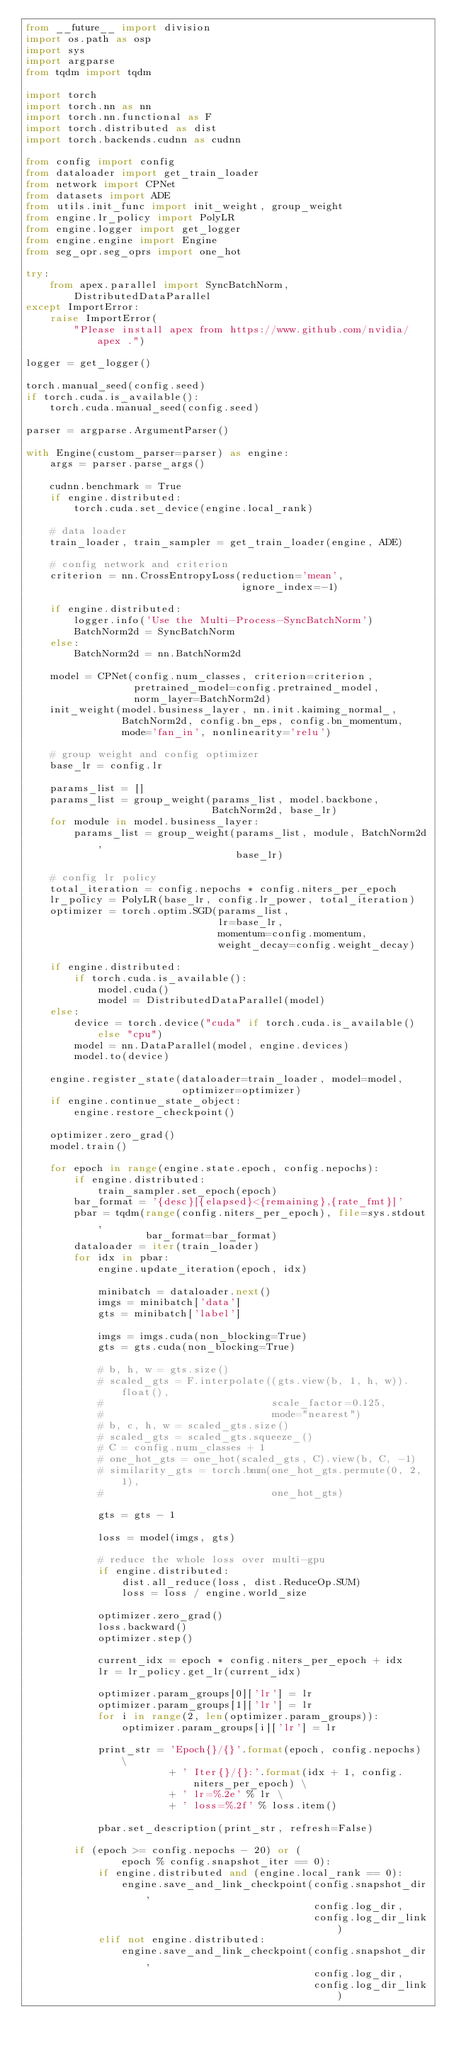<code> <loc_0><loc_0><loc_500><loc_500><_Python_>from __future__ import division
import os.path as osp
import sys
import argparse
from tqdm import tqdm

import torch
import torch.nn as nn
import torch.nn.functional as F
import torch.distributed as dist
import torch.backends.cudnn as cudnn

from config import config
from dataloader import get_train_loader
from network import CPNet
from datasets import ADE
from utils.init_func import init_weight, group_weight
from engine.lr_policy import PolyLR
from engine.logger import get_logger
from engine.engine import Engine
from seg_opr.seg_oprs import one_hot

try:
    from apex.parallel import SyncBatchNorm, DistributedDataParallel
except ImportError:
    raise ImportError(
        "Please install apex from https://www.github.com/nvidia/apex .")

logger = get_logger()

torch.manual_seed(config.seed)
if torch.cuda.is_available():
    torch.cuda.manual_seed(config.seed)

parser = argparse.ArgumentParser()

with Engine(custom_parser=parser) as engine:
    args = parser.parse_args()

    cudnn.benchmark = True
    if engine.distributed:
        torch.cuda.set_device(engine.local_rank)

    # data loader
    train_loader, train_sampler = get_train_loader(engine, ADE)

    # config network and criterion
    criterion = nn.CrossEntropyLoss(reduction='mean',
                                    ignore_index=-1)

    if engine.distributed:
        logger.info('Use the Multi-Process-SyncBatchNorm')
        BatchNorm2d = SyncBatchNorm
    else:
        BatchNorm2d = nn.BatchNorm2d

    model = CPNet(config.num_classes, criterion=criterion,
                  pretrained_model=config.pretrained_model,
                  norm_layer=BatchNorm2d)
    init_weight(model.business_layer, nn.init.kaiming_normal_,
                BatchNorm2d, config.bn_eps, config.bn_momentum,
                mode='fan_in', nonlinearity='relu')

    # group weight and config optimizer
    base_lr = config.lr

    params_list = []
    params_list = group_weight(params_list, model.backbone,
                               BatchNorm2d, base_lr)
    for module in model.business_layer:
        params_list = group_weight(params_list, module, BatchNorm2d,
                                   base_lr)

    # config lr policy
    total_iteration = config.nepochs * config.niters_per_epoch
    lr_policy = PolyLR(base_lr, config.lr_power, total_iteration)
    optimizer = torch.optim.SGD(params_list,
                                lr=base_lr,
                                momentum=config.momentum,
                                weight_decay=config.weight_decay)

    if engine.distributed:
        if torch.cuda.is_available():
            model.cuda()
            model = DistributedDataParallel(model)
    else:
        device = torch.device("cuda" if torch.cuda.is_available() else "cpu")
        model = nn.DataParallel(model, engine.devices)
        model.to(device)

    engine.register_state(dataloader=train_loader, model=model,
                          optimizer=optimizer)
    if engine.continue_state_object:
        engine.restore_checkpoint()

    optimizer.zero_grad()
    model.train()

    for epoch in range(engine.state.epoch, config.nepochs):
        if engine.distributed:
            train_sampler.set_epoch(epoch)
        bar_format = '{desc}[{elapsed}<{remaining},{rate_fmt}]'
        pbar = tqdm(range(config.niters_per_epoch), file=sys.stdout,
                    bar_format=bar_format)
        dataloader = iter(train_loader)
        for idx in pbar:
            engine.update_iteration(epoch, idx)

            minibatch = dataloader.next()
            imgs = minibatch['data']
            gts = minibatch['label']

            imgs = imgs.cuda(non_blocking=True)
            gts = gts.cuda(non_blocking=True)

            # b, h, w = gts.size()
            # scaled_gts = F.interpolate((gts.view(b, 1, h, w)).float(),
            #                            scale_factor=0.125,
            #                            mode="nearest")
            # b, c, h, w = scaled_gts.size()
            # scaled_gts = scaled_gts.squeeze_()
            # C = config.num_classes + 1
            # one_hot_gts = one_hot(scaled_gts, C).view(b, C, -1)
            # similarity_gts = torch.bmm(one_hot_gts.permute(0, 2, 1),
            #                            one_hot_gts)

            gts = gts - 1

            loss = model(imgs, gts)

            # reduce the whole loss over multi-gpu
            if engine.distributed:
                dist.all_reduce(loss, dist.ReduceOp.SUM)
                loss = loss / engine.world_size

            optimizer.zero_grad()
            loss.backward()
            optimizer.step()

            current_idx = epoch * config.niters_per_epoch + idx
            lr = lr_policy.get_lr(current_idx)

            optimizer.param_groups[0]['lr'] = lr
            optimizer.param_groups[1]['lr'] = lr
            for i in range(2, len(optimizer.param_groups)):
                optimizer.param_groups[i]['lr'] = lr

            print_str = 'Epoch{}/{}'.format(epoch, config.nepochs) \
                        + ' Iter{}/{}:'.format(idx + 1, config.niters_per_epoch) \
                        + ' lr=%.2e' % lr \
                        + ' loss=%.2f' % loss.item()

            pbar.set_description(print_str, refresh=False)

        if (epoch >= config.nepochs - 20) or (
                epoch % config.snapshot_iter == 0):
            if engine.distributed and (engine.local_rank == 0):
                engine.save_and_link_checkpoint(config.snapshot_dir,
                                                config.log_dir,
                                                config.log_dir_link)
            elif not engine.distributed:
                engine.save_and_link_checkpoint(config.snapshot_dir,
                                                config.log_dir,
                                                config.log_dir_link)
</code> 